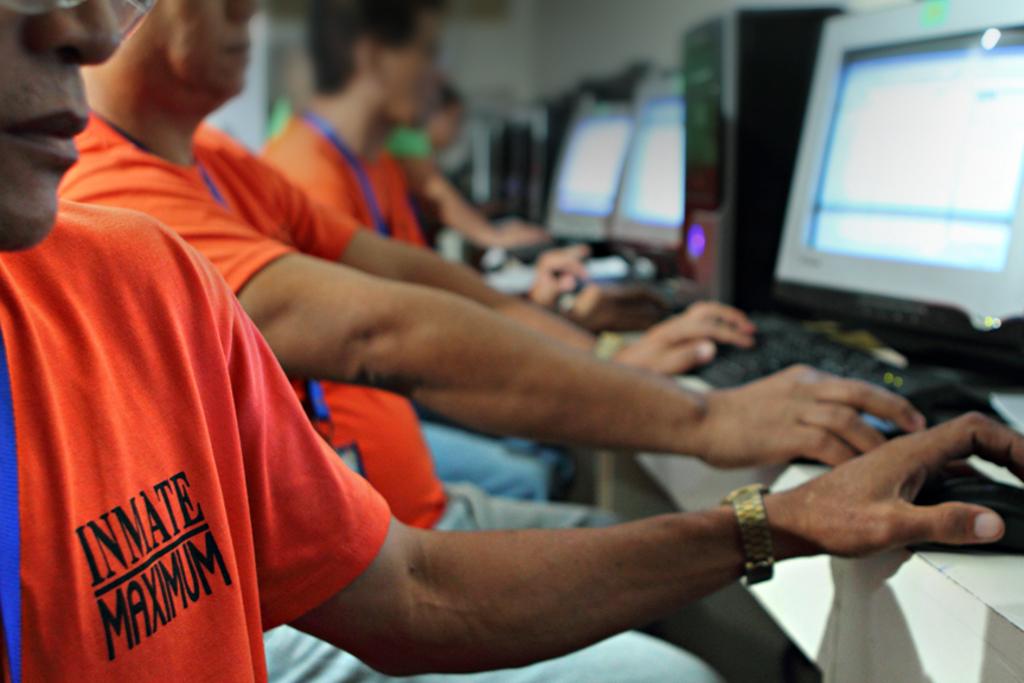What does the man's shirt indicate that he is?
Make the answer very short. Inmate. 